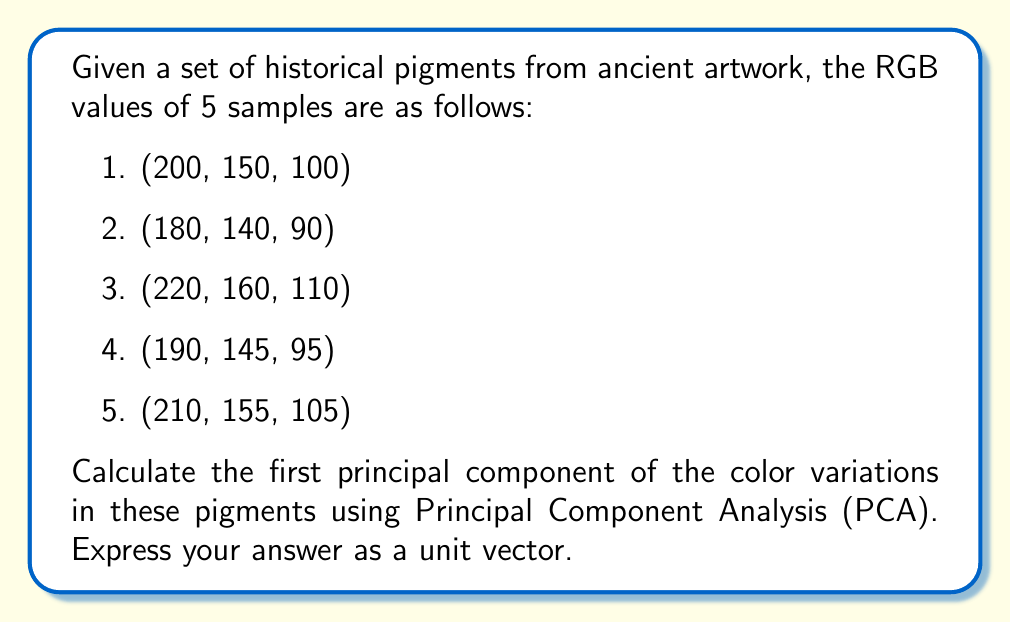Solve this math problem. To calculate the first principal component using PCA:

1. Center the data by subtracting the mean from each column:
   Mean: (200, 150, 100)
   Centered data:
   $$ X = \begin{bmatrix}
   0 & 0 & 0 \\
   -20 & -10 & -10 \\
   20 & 10 & 10 \\
   -10 & -5 & -5 \\
   10 & 5 & 5
   \end{bmatrix} $$

2. Compute the covariance matrix:
   $$ C = \frac{1}{n-1} X^T X = \begin{bmatrix}
   200 & 100 & 100 \\
   100 & 50 & 50 \\
   100 & 50 & 50
   \end{bmatrix} $$

3. Find eigenvectors and eigenvalues of C:
   Characteristic equation: $\det(C - \lambda I) = 0$
   Solving this yields eigenvalues: $\lambda_1 = 300, \lambda_2 = 0, \lambda_3 = 0$

4. The eigenvector corresponding to the largest eigenvalue (300) is the first principal component:
   $$ (C - 300I)v = 0 $$
   Solving this system gives: $v = k(1, 0.5, 0.5)$ where $k$ is a constant

5. Normalize the eigenvector to get a unit vector:
   $$ \vec{v} = \frac{(1, 0.5, 0.5)}{\sqrt{1^2 + 0.5^2 + 0.5^2}} = \frac{(1, 0.5, 0.5)}{\sqrt{1.5}} $$
Answer: $(\frac{\sqrt{2}}{3}, \frac{1}{3}, \frac{1}{3})$ 